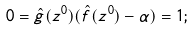Convert formula to latex. <formula><loc_0><loc_0><loc_500><loc_500>0 = \hat { g } ( z ^ { 0 } ) ( \hat { f } ( z ^ { 0 } ) - \alpha ) = 1 ;</formula> 